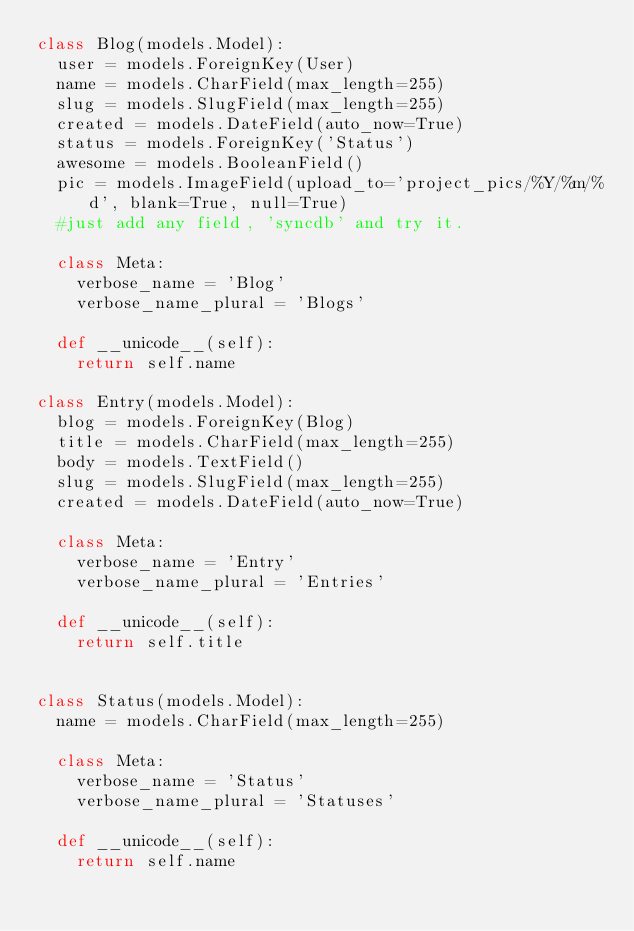Convert code to text. <code><loc_0><loc_0><loc_500><loc_500><_Python_>class Blog(models.Model):
	user = models.ForeignKey(User)
	name = models.CharField(max_length=255)
	slug = models.SlugField(max_length=255)
	created = models.DateField(auto_now=True)
	status = models.ForeignKey('Status')
	awesome = models.BooleanField()
	pic = models.ImageField(upload_to='project_pics/%Y/%m/%d', blank=True, null=True)
	#just add any field, 'syncdb' and try it.

	class Meta:
		verbose_name = 'Blog'
		verbose_name_plural = 'Blogs'

	def __unicode__(self):
		return self.name

class Entry(models.Model):
	blog = models.ForeignKey(Blog)
	title = models.CharField(max_length=255)
	body = models.TextField()
	slug = models.SlugField(max_length=255)
	created = models.DateField(auto_now=True)

	class Meta:
		verbose_name = 'Entry'
		verbose_name_plural = 'Entries'

	def __unicode__(self):
		return self.title
		

class Status(models.Model):
	name = models.CharField(max_length=255)

	class Meta:
		verbose_name = 'Status'
		verbose_name_plural = 'Statuses'
	
	def __unicode__(self):
		return self.name</code> 